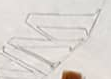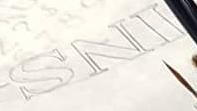What words are shown in these images in order, separated by a semicolon? W; INS 